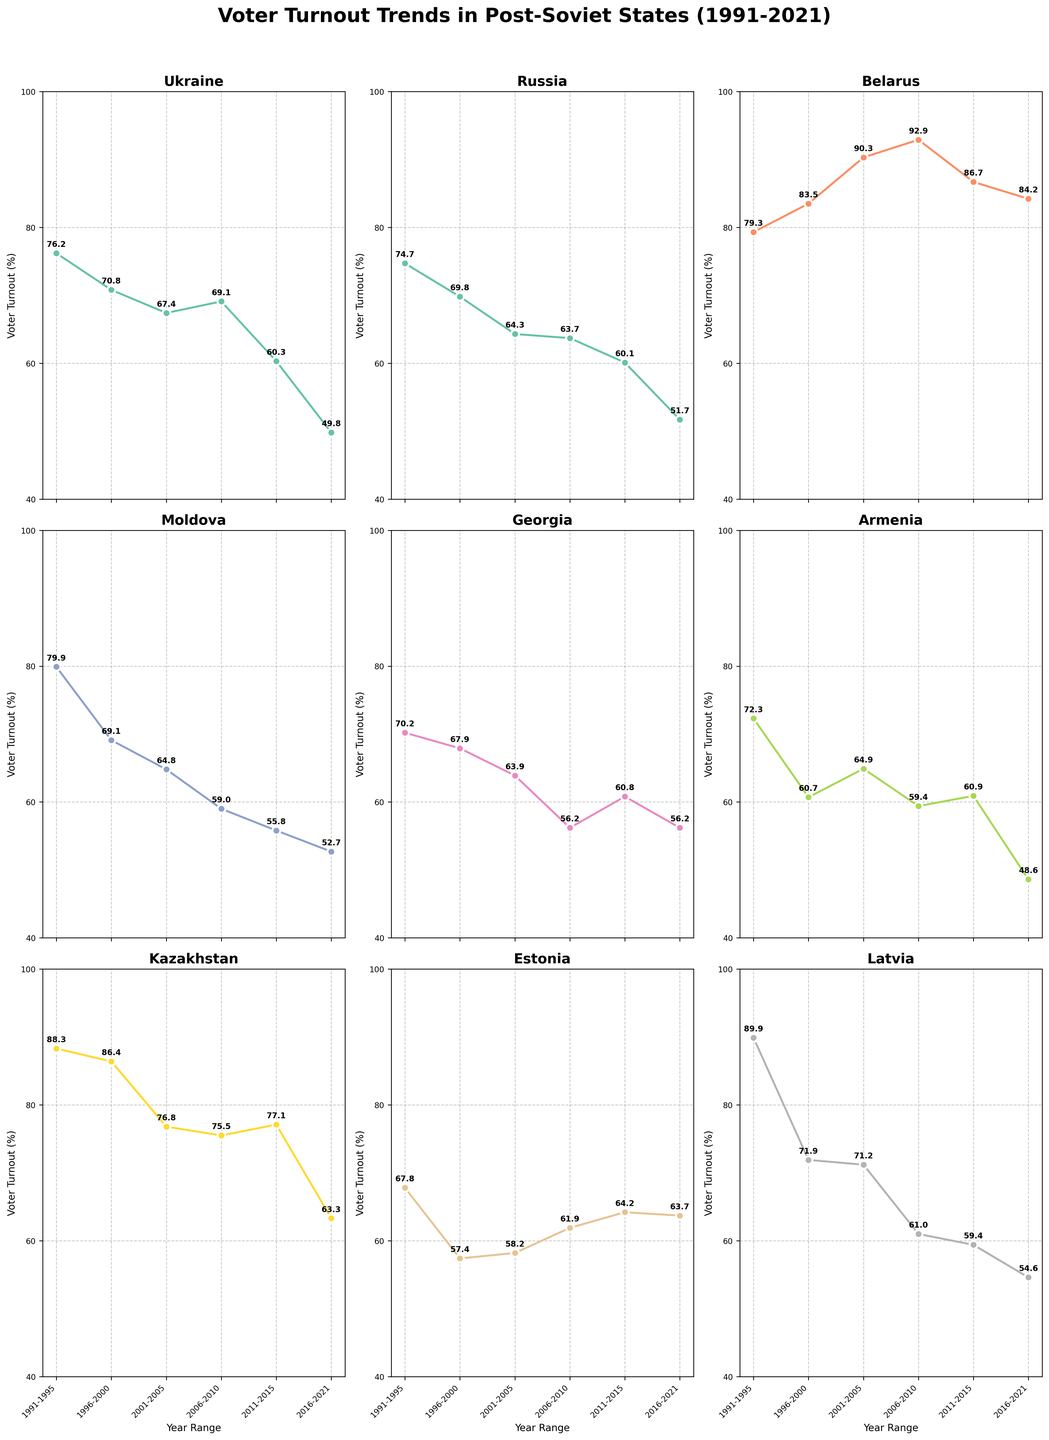Which post-Soviet state had the highest voter turnout percentage in the period 1991-1995? From the figure, look at each subplot for the years 1991-1995 and identify the highest percentage. Belarus had the highest voter turnout percentage at 89.9%.
Answer: Belarus What is the overall trend in voter turnout in Ukraine from 1991 to 2021? Examine the plot for Ukraine and observe the changes in voter turnout percentages over the years. The turnout starts high at 76.2% and decreases progressively to 49.8% in 2021.
Answer: Decreasing Among the shown countries, which had consistently increasing voter turnout percentages? Visually inspect all subplots to identify any country where the turnout percentages consistently increase over each period. No country shows a consistently increasing trend; most trends are declining.
Answer: None Compare voter turnout in Russia and Ukraine in the period 2016-2021. Which country had higher turnout during this period? Look at the plots for Russia and Ukraine, specifically for the years 2016-2021. Russia had a higher voter turnout at 51.7% compared to Ukraine's 49.8%.
Answer: Russia What is the difference in voter turnout between the highest and the lowest turnout figure in the period 1991-2021 for Georgia? From Georgia's subplot, the highest turnout is 70.2% in 1991-1995 and the lowest is 56.2% in 2006-2010 and 2016-2021. The difference is 70.2% - 56.2% = 14%.
Answer: 14% Which countries had a higher voter turnout in the period 2001-2005 than in the period 1996-2000? Observe each subplot for countries where the percentage for 2001-2005 is higher than 1996-2000. Only Armenia showed this with 64.9% in 2001-2005 compared to 60.7% in 1996-2000.
Answer: Armenia What is the average voter turnout in Estonia over the five periods given? From Estonia's subplot, sum the voter turnout percentages (67.8 + 57.4 + 58.2 + 61.9 + 64.2 + 63.7) / 6. The average is (373.2 / 6) = 62.2%.
Answer: 62.2% Among Latvia, Moldova, and Armenia, which country had the lowest voter turnout in the period 2016-2021? Compare the voter turnout for the 2016-2021 period for these countries. Armenia had the lowest turnout at 48.6% compared to Latvia's 54.6% and Moldova's 52.7%.
Answer: Armenia Which country had the most significant drop in voter turnout percentage from 1991-1995 to 2016-2021? Calculate the difference for each country and compare. Latvia showed a drop from 89.9% to 54.6%, which is 35.3%, the most significant.
Answer: Latvia How many countries had their voter turnout below 60% in the period 2016-2021? Refer to each subplot for the period 2016-2021. Ukraine, Russia, Moldova, Georgia, Armenia, and Latvia had turnout figures below 60%.
Answer: 6 